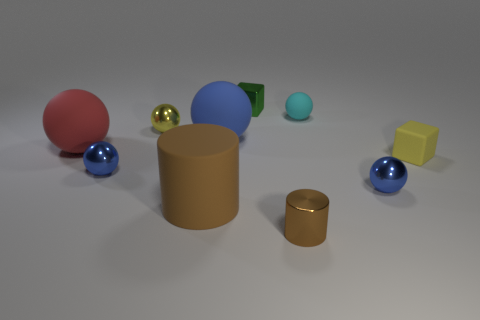Subtract all red rubber balls. How many balls are left? 5 Subtract all blue balls. How many balls are left? 3 Subtract 2 spheres. How many spheres are left? 4 Subtract all spheres. How many objects are left? 4 Subtract all brown blocks. How many purple cylinders are left? 0 Subtract 0 cyan cylinders. How many objects are left? 10 Subtract all green cylinders. Subtract all blue blocks. How many cylinders are left? 2 Subtract all small green cubes. Subtract all small brown cylinders. How many objects are left? 8 Add 2 matte cubes. How many matte cubes are left? 3 Add 10 tiny cyan matte blocks. How many tiny cyan matte blocks exist? 10 